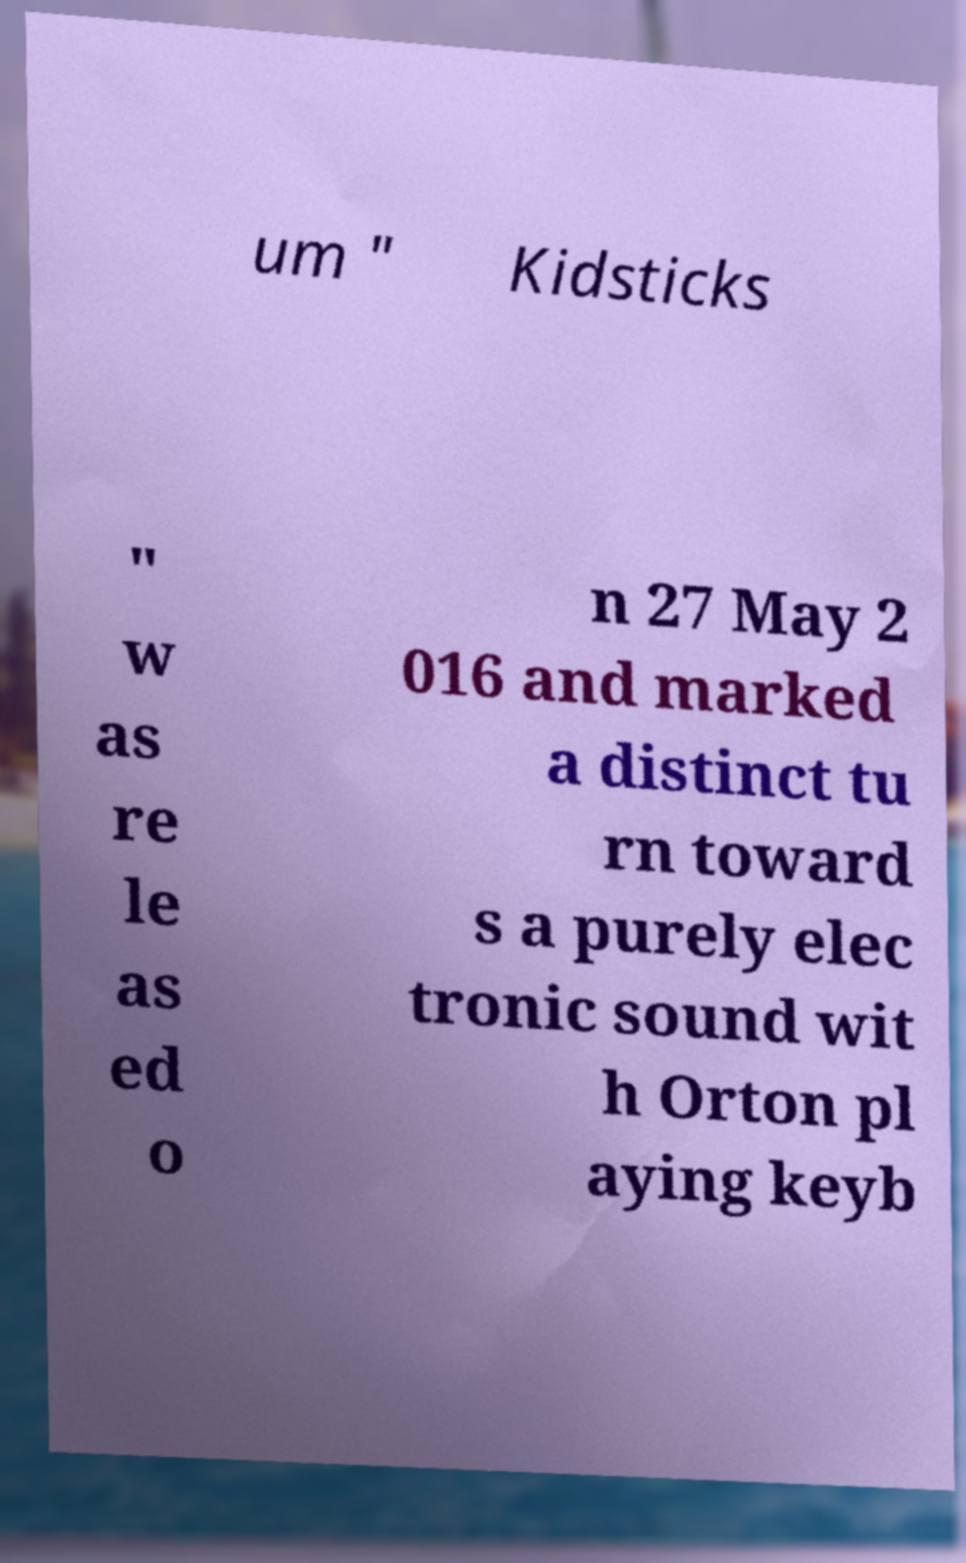What messages or text are displayed in this image? I need them in a readable, typed format. um " Kidsticks " w as re le as ed o n 27 May 2 016 and marked a distinct tu rn toward s a purely elec tronic sound wit h Orton pl aying keyb 